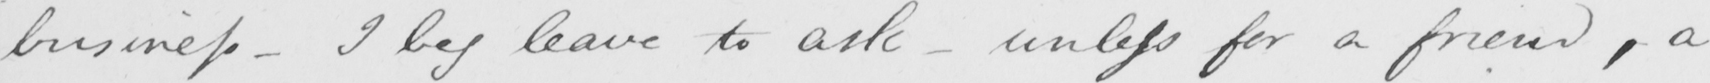What is written in this line of handwriting? business  _  I beg leave to ask  _  unless for a friend , a 